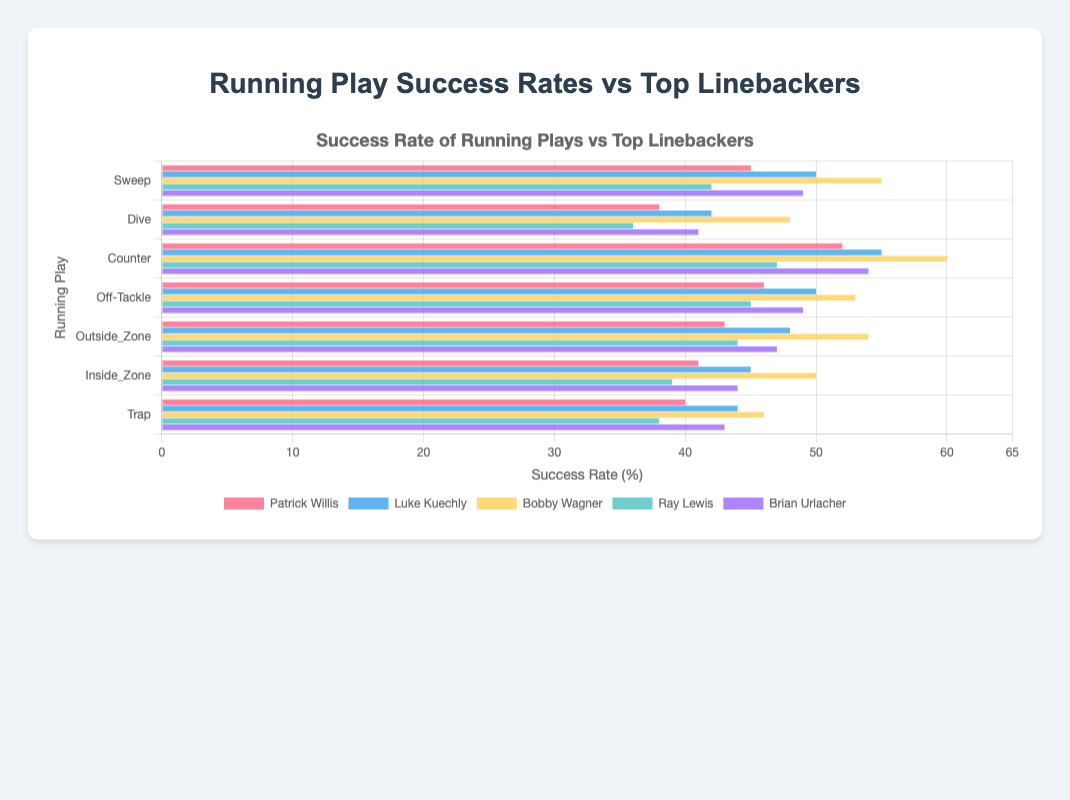Which running play has the highest success rate against Patrick Willis? The bar corresponding to the 'Counter' running play is the longest for Patrick Willis, indicating the highest success rate.
Answer: Counter Which running play has the lowest success rate against Ray Lewis? The 'Dive' bar is the shortest for Ray Lewis, showing the lowest success rate.
Answer: Dive Which linebacker has the highest success rate against the 'Inside Zone' play? The 'Inside Zone' bar corresponding to Bobby Wagner is the longest among all the linebackers, indicating his highest success rate.
Answer: Bobby Wagner What is the average success rate of the 'Sweep' play across all linebackers? The success rates for 'Sweep' are 45, 50, 55, 42, and 49. Summing these gives 241. Dividing by 5 gives an average success rate of 48.2.
Answer: 48.2 Which linebacker is associated with the shortest bar in the 'Trap' play? The 'Trap' play's shortest bar corresponds to Ray Lewis with a value of 38.
Answer: Ray Lewis Does the 'Off-Tackle' play have a higher success rate against Brian Urlacher or Luke Kuechly? The 'Off-Tackle' bar for Brian Urlacher is 49, while for Luke Kuechly it is 50. Luke Kuechly has the higher success rate.
Answer: Luke Kuechly Compare the success rates of the 'Outside Zone' play against Patrick Willis and Ray Lewis. Which one is higher and by how much? The 'Outside Zone' success rate is 43 for Patrick Willis and 44 for Ray Lewis. Ray Lewis's rate is higher by 1.
Answer: Ray Lewis by 1 What is the difference in success rate of the 'Dive' play between Bobby Wagner and Ray Lewis? The 'Dive' success rate for Bobby Wagner is 48 and for Ray Lewis is 36. The difference is 48 - 36 = 12.
Answer: 12 How many running plays have a success rate of 50 or more against Luke Kuechly? The running plays with success rates of 50 or more against Luke Kuechly are 'Sweep', 'Counter', and 'Off-Tackle'. So, there are 3 plays.
Answer: 3 Which running play has the most consistent (least variation) success rates across all linebackers? By observing the length of the bars across the linebackers for each play, 'Off-Tackle' appears to have the least variation in bar lengths.
Answer: Off-Tackle 